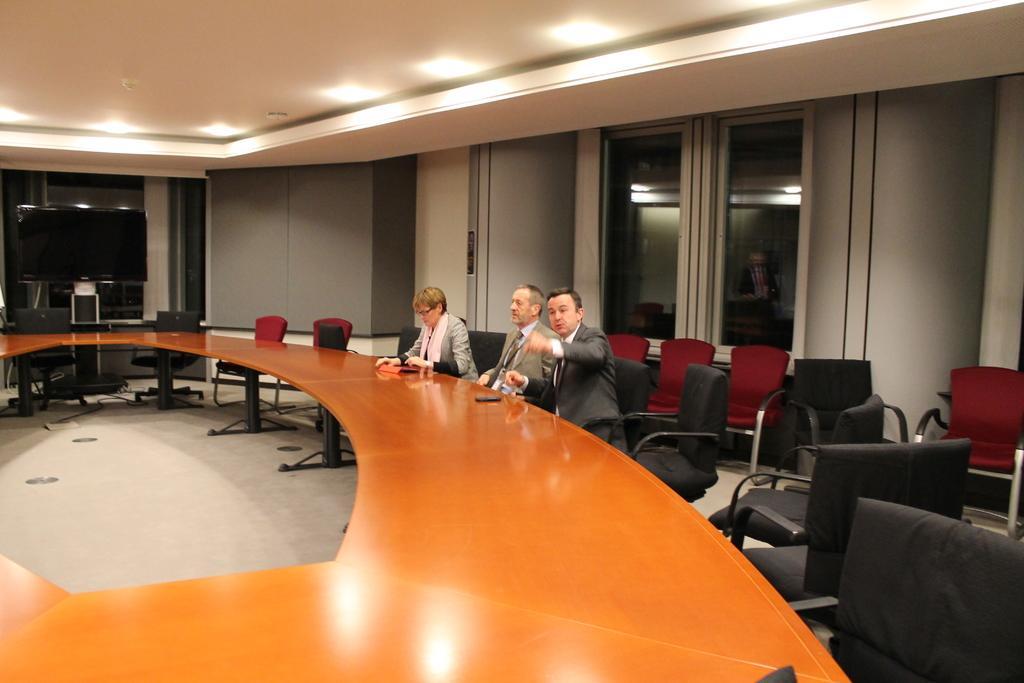In one or two sentences, can you explain what this image depicts? It looks like a conference room. In this image, 3 peoples are sat on the chair. We can see red color chairs ,black color chairs. And orange color table and floor. We can see white color roof with lights. Here we can see glass door, ash color wall. There is a television here and stand. 